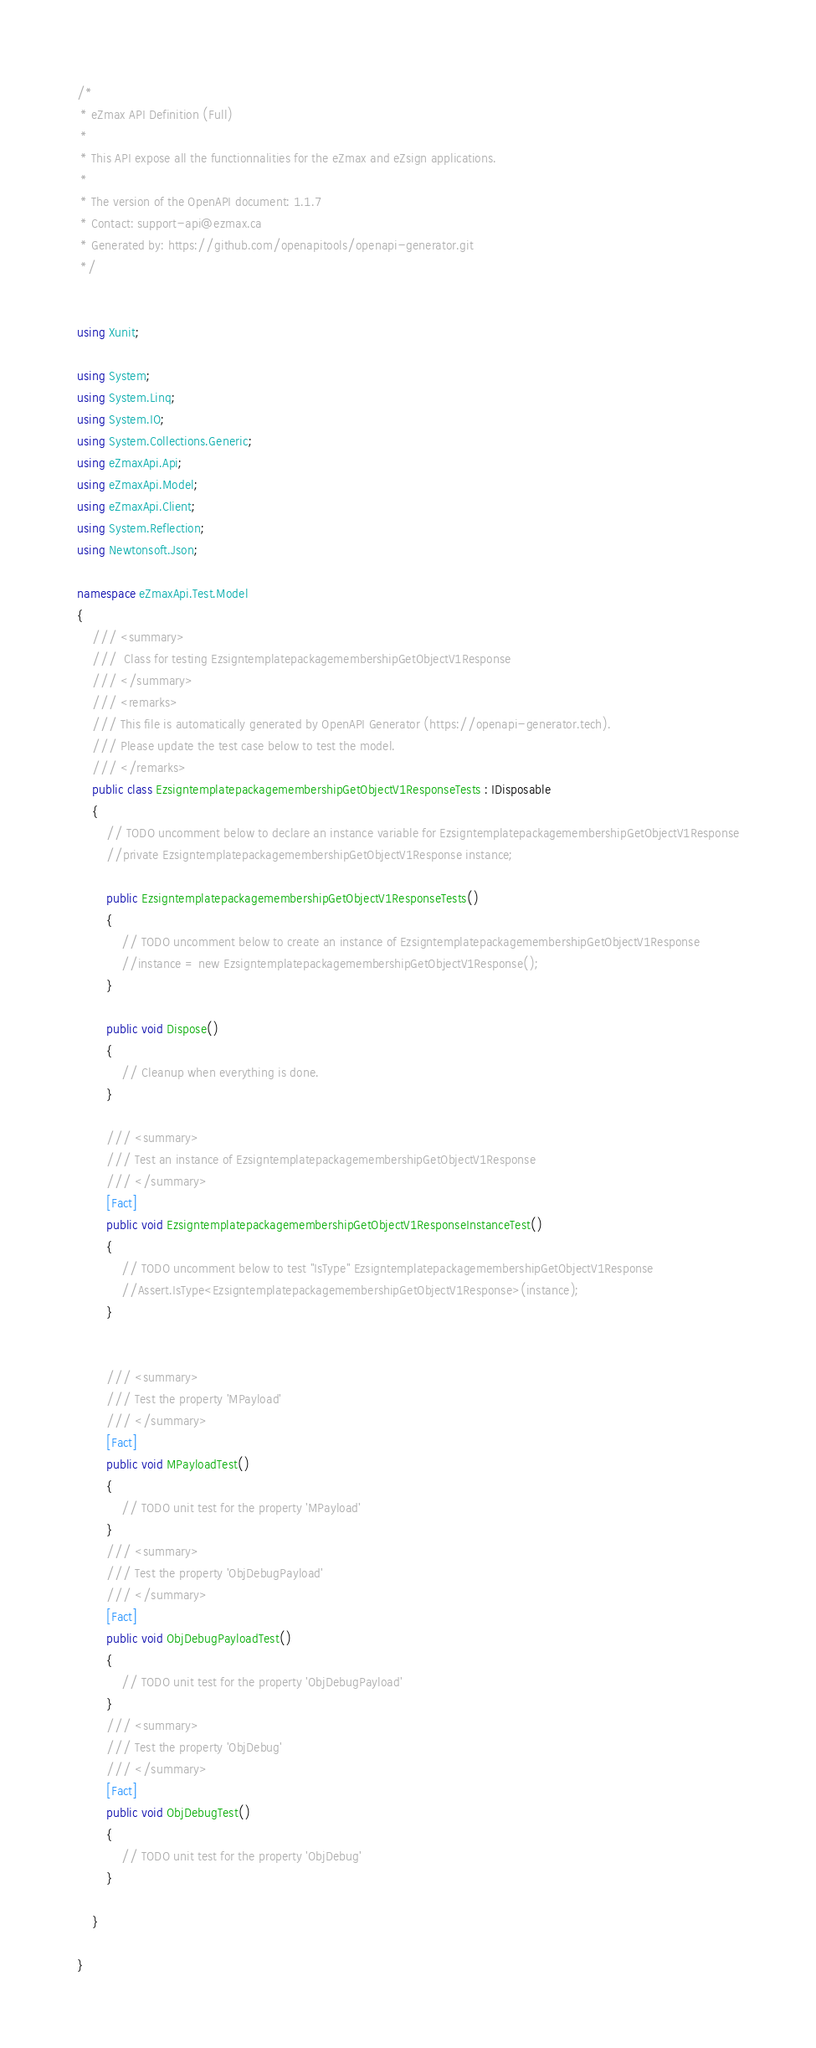Convert code to text. <code><loc_0><loc_0><loc_500><loc_500><_C#_>/*
 * eZmax API Definition (Full)
 *
 * This API expose all the functionnalities for the eZmax and eZsign applications.
 *
 * The version of the OpenAPI document: 1.1.7
 * Contact: support-api@ezmax.ca
 * Generated by: https://github.com/openapitools/openapi-generator.git
 */


using Xunit;

using System;
using System.Linq;
using System.IO;
using System.Collections.Generic;
using eZmaxApi.Api;
using eZmaxApi.Model;
using eZmaxApi.Client;
using System.Reflection;
using Newtonsoft.Json;

namespace eZmaxApi.Test.Model
{
    /// <summary>
    ///  Class for testing EzsigntemplatepackagemembershipGetObjectV1Response
    /// </summary>
    /// <remarks>
    /// This file is automatically generated by OpenAPI Generator (https://openapi-generator.tech).
    /// Please update the test case below to test the model.
    /// </remarks>
    public class EzsigntemplatepackagemembershipGetObjectV1ResponseTests : IDisposable
    {
        // TODO uncomment below to declare an instance variable for EzsigntemplatepackagemembershipGetObjectV1Response
        //private EzsigntemplatepackagemembershipGetObjectV1Response instance;

        public EzsigntemplatepackagemembershipGetObjectV1ResponseTests()
        {
            // TODO uncomment below to create an instance of EzsigntemplatepackagemembershipGetObjectV1Response
            //instance = new EzsigntemplatepackagemembershipGetObjectV1Response();
        }

        public void Dispose()
        {
            // Cleanup when everything is done.
        }

        /// <summary>
        /// Test an instance of EzsigntemplatepackagemembershipGetObjectV1Response
        /// </summary>
        [Fact]
        public void EzsigntemplatepackagemembershipGetObjectV1ResponseInstanceTest()
        {
            // TODO uncomment below to test "IsType" EzsigntemplatepackagemembershipGetObjectV1Response
            //Assert.IsType<EzsigntemplatepackagemembershipGetObjectV1Response>(instance);
        }


        /// <summary>
        /// Test the property 'MPayload'
        /// </summary>
        [Fact]
        public void MPayloadTest()
        {
            // TODO unit test for the property 'MPayload'
        }
        /// <summary>
        /// Test the property 'ObjDebugPayload'
        /// </summary>
        [Fact]
        public void ObjDebugPayloadTest()
        {
            // TODO unit test for the property 'ObjDebugPayload'
        }
        /// <summary>
        /// Test the property 'ObjDebug'
        /// </summary>
        [Fact]
        public void ObjDebugTest()
        {
            // TODO unit test for the property 'ObjDebug'
        }

    }

}
</code> 